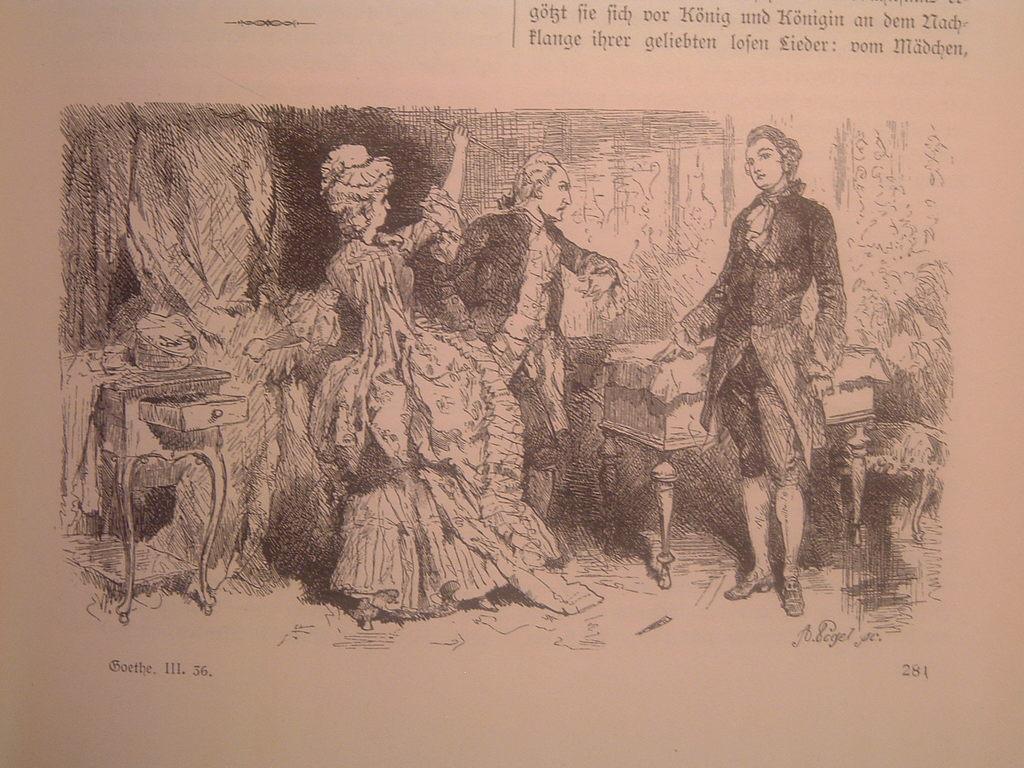Could you give a brief overview of what you see in this image? In this image I see the sketch of 3 persons and I see few things and I see something is written over here and I see something is written over here too. 